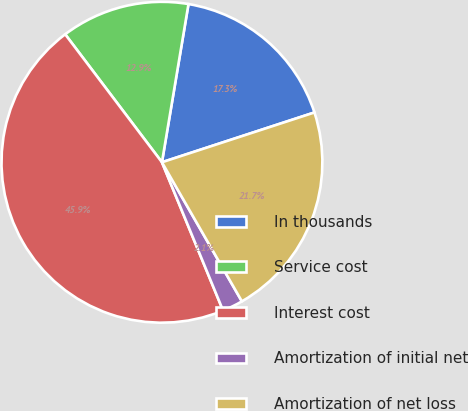<chart> <loc_0><loc_0><loc_500><loc_500><pie_chart><fcel>In thousands<fcel>Service cost<fcel>Interest cost<fcel>Amortization of initial net<fcel>Amortization of net loss<nl><fcel>17.33%<fcel>12.95%<fcel>45.92%<fcel>2.08%<fcel>21.72%<nl></chart> 